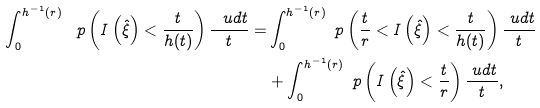Convert formula to latex. <formula><loc_0><loc_0><loc_500><loc_500>\int _ { 0 } ^ { h ^ { - 1 } ( r ) } \ p \left ( I \left ( \hat { \xi } \right ) < \frac { t } { h ( t ) } \right ) \frac { \ u d t } { t } = & \int _ { 0 } ^ { h ^ { - 1 } ( r ) } \ p \left ( \frac { t } { r } < I \left ( \hat { \xi } \right ) < \frac { t } { h ( t ) } \right ) \frac { \ u d t } { t } \\ & + \int _ { 0 } ^ { h ^ { - 1 } ( r ) } \ p \left ( I \left ( \hat { \xi } \right ) < \frac { t } { r } \right ) \frac { \ u d t } { t } ,</formula> 